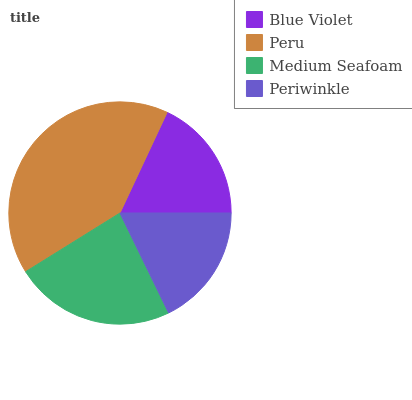Is Periwinkle the minimum?
Answer yes or no. Yes. Is Peru the maximum?
Answer yes or no. Yes. Is Medium Seafoam the minimum?
Answer yes or no. No. Is Medium Seafoam the maximum?
Answer yes or no. No. Is Peru greater than Medium Seafoam?
Answer yes or no. Yes. Is Medium Seafoam less than Peru?
Answer yes or no. Yes. Is Medium Seafoam greater than Peru?
Answer yes or no. No. Is Peru less than Medium Seafoam?
Answer yes or no. No. Is Medium Seafoam the high median?
Answer yes or no. Yes. Is Blue Violet the low median?
Answer yes or no. Yes. Is Peru the high median?
Answer yes or no. No. Is Periwinkle the low median?
Answer yes or no. No. 